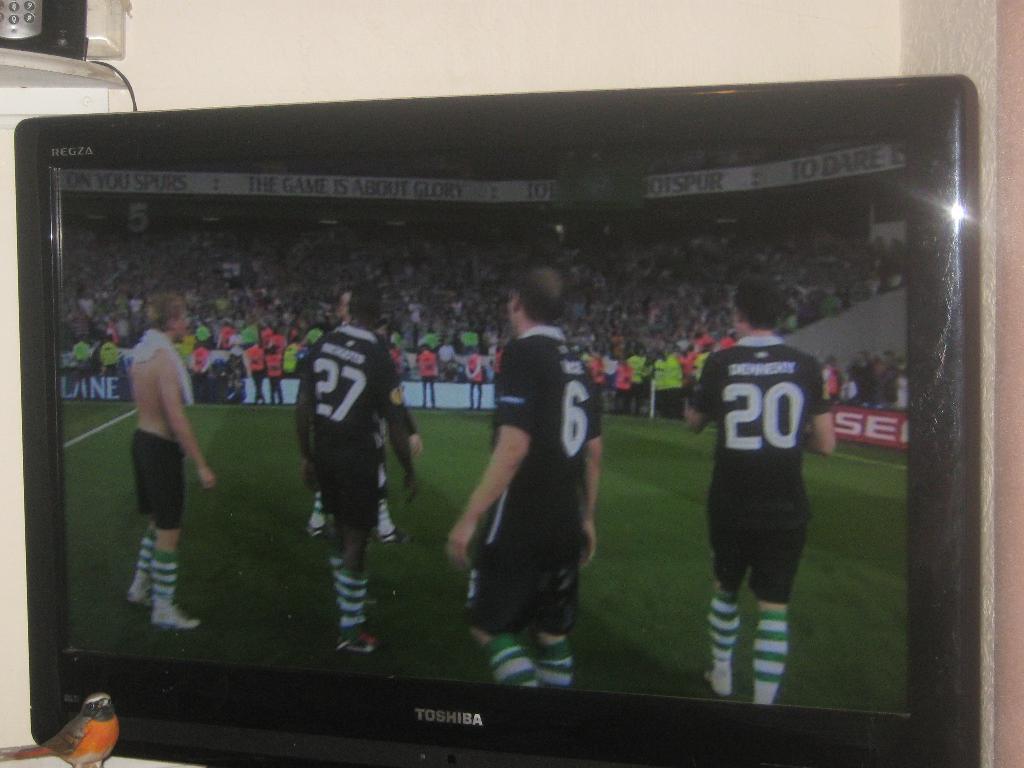What is his number at the far right end?
Ensure brevity in your answer.  20. What is the number on the mans shirt to the very right?
Offer a very short reply. 20. 